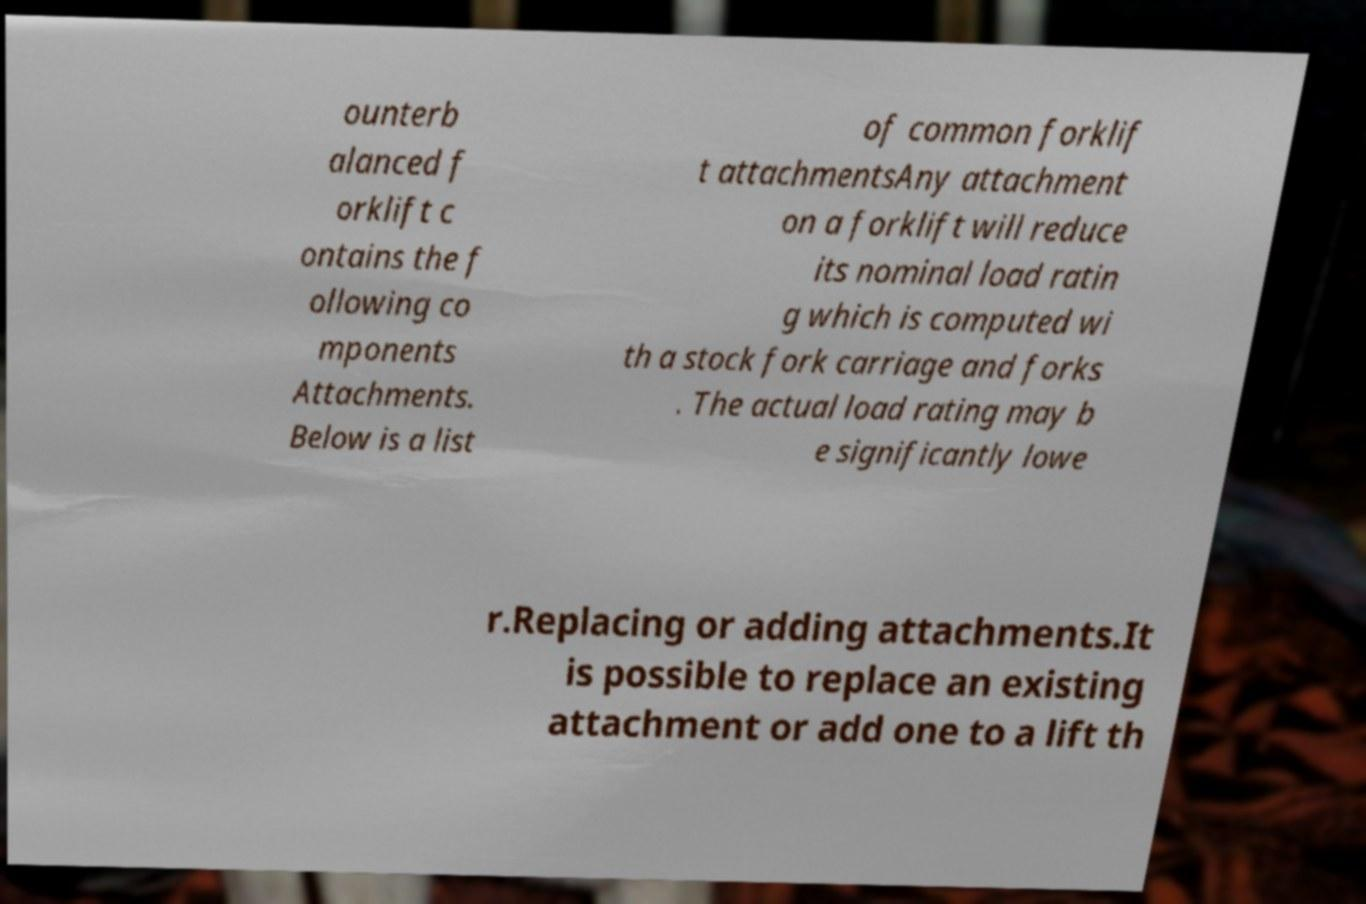There's text embedded in this image that I need extracted. Can you transcribe it verbatim? ounterb alanced f orklift c ontains the f ollowing co mponents Attachments. Below is a list of common forklif t attachmentsAny attachment on a forklift will reduce its nominal load ratin g which is computed wi th a stock fork carriage and forks . The actual load rating may b e significantly lowe r.Replacing or adding attachments.It is possible to replace an existing attachment or add one to a lift th 